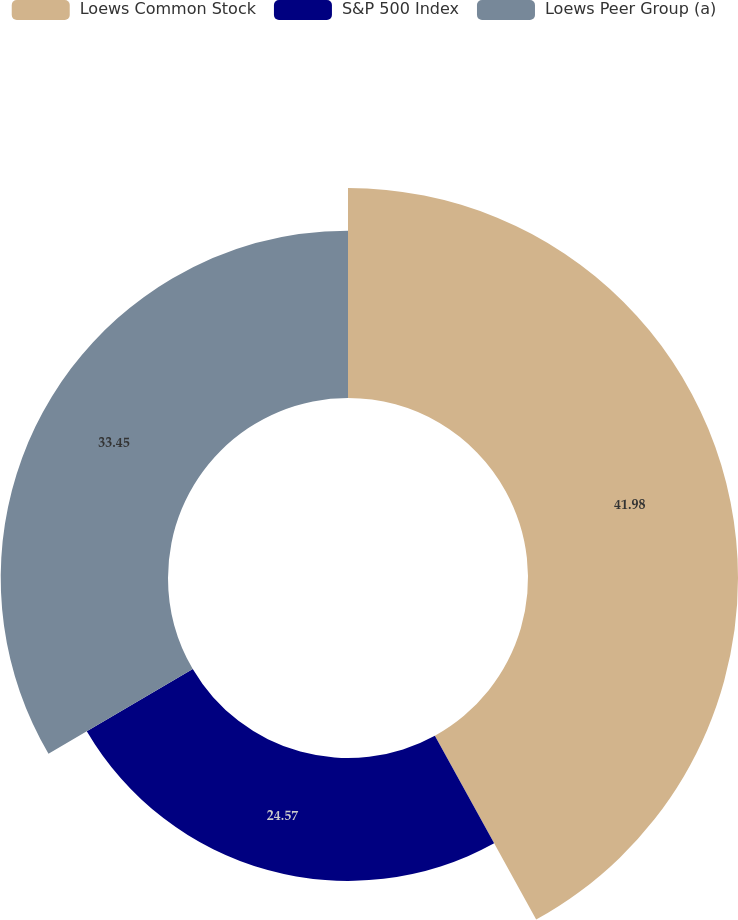<chart> <loc_0><loc_0><loc_500><loc_500><pie_chart><fcel>Loews Common Stock<fcel>S&P 500 Index<fcel>Loews Peer Group (a)<nl><fcel>41.99%<fcel>24.57%<fcel>33.45%<nl></chart> 